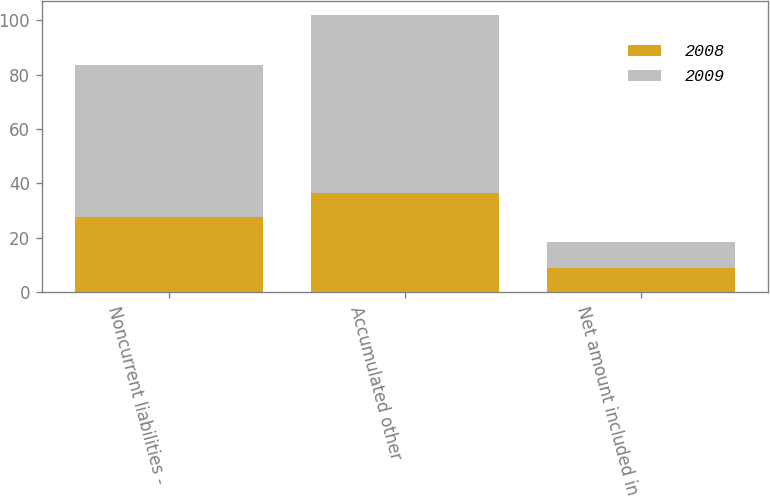<chart> <loc_0><loc_0><loc_500><loc_500><stacked_bar_chart><ecel><fcel>Noncurrent liabilities -<fcel>Accumulated other<fcel>Net amount included in<nl><fcel>2008<fcel>27.5<fcel>36.4<fcel>8.9<nl><fcel>2009<fcel>56.1<fcel>65.6<fcel>9.5<nl></chart> 